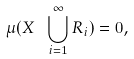<formula> <loc_0><loc_0><loc_500><loc_500>\mu ( X \ \bigcup _ { i = 1 } ^ { \infty } R _ { i } ) = 0 ,</formula> 